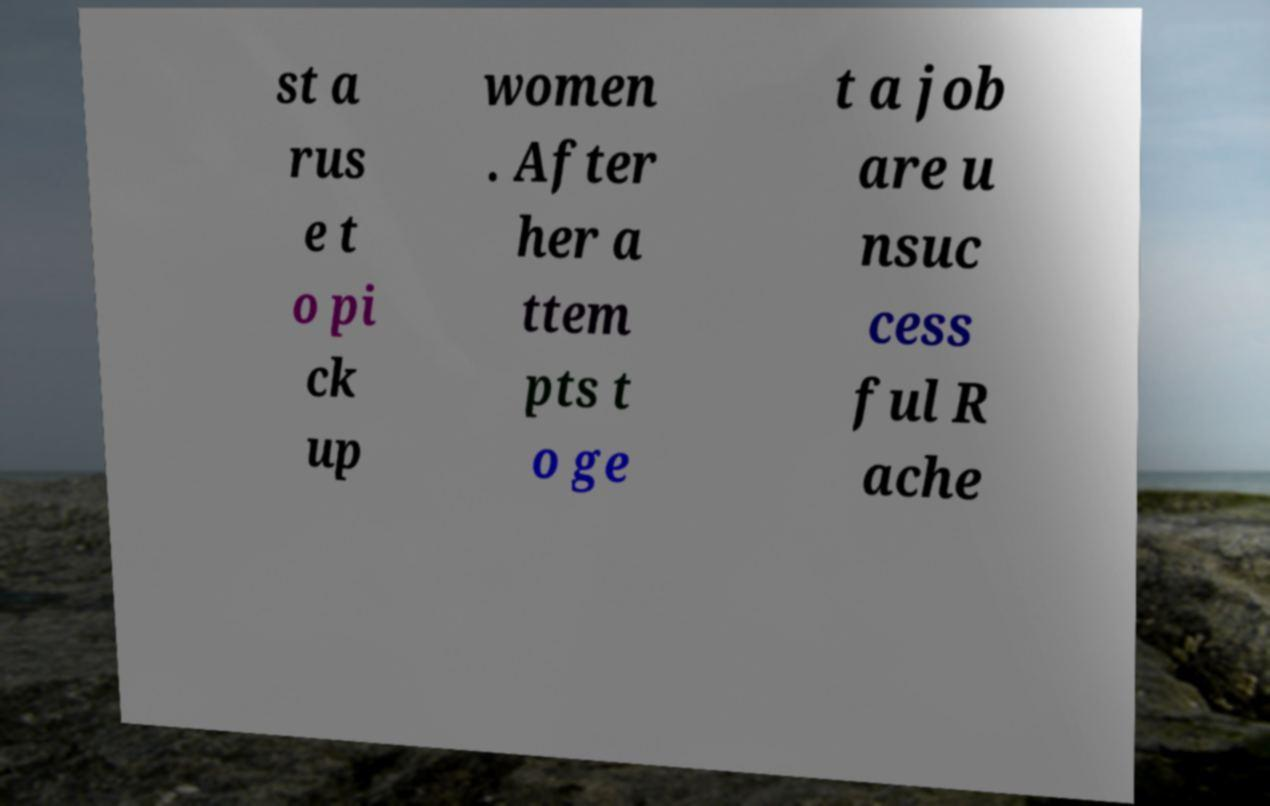For documentation purposes, I need the text within this image transcribed. Could you provide that? st a rus e t o pi ck up women . After her a ttem pts t o ge t a job are u nsuc cess ful R ache 